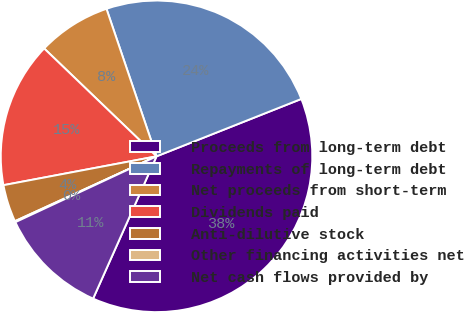<chart> <loc_0><loc_0><loc_500><loc_500><pie_chart><fcel>Proceeds from long-term debt<fcel>Repayments of long-term debt<fcel>Net proceeds from short-term<fcel>Dividends paid<fcel>Anti-dilutive stock<fcel>Other financing activities net<fcel>Net cash flows provided by<nl><fcel>37.68%<fcel>24.2%<fcel>7.62%<fcel>15.14%<fcel>3.87%<fcel>0.11%<fcel>11.38%<nl></chart> 